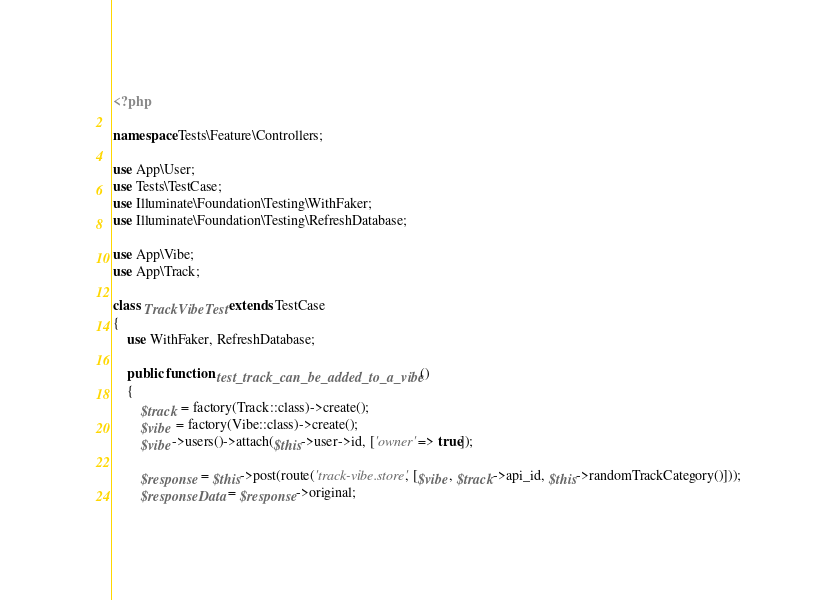Convert code to text. <code><loc_0><loc_0><loc_500><loc_500><_PHP_><?php

namespace Tests\Feature\Controllers;

use App\User;
use Tests\TestCase;
use Illuminate\Foundation\Testing\WithFaker;
use Illuminate\Foundation\Testing\RefreshDatabase;

use App\Vibe;
use App\Track;

class TrackVibeTest extends TestCase
{
	use WithFaker, RefreshDatabase;

    public function test_track_can_be_added_to_a_vibe()
    {
    	$track = factory(Track::class)->create();
    	$vibe = factory(Vibe::class)->create();
    	$vibe->users()->attach($this->user->id, ['owner' => true]);

    	$response = $this->post(route('track-vibe.store', [$vibe, $track->api_id, $this->randomTrackCategory()]));
        $responseData = $response->original;
</code> 